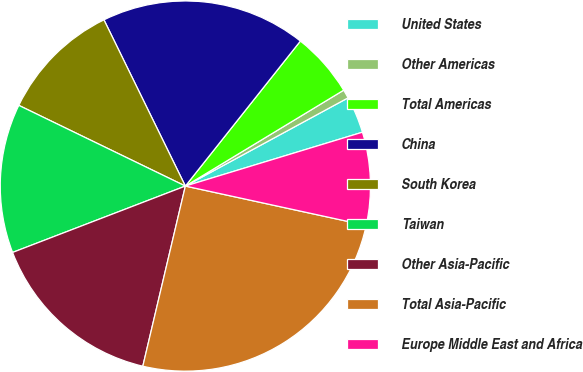Convert chart to OTSL. <chart><loc_0><loc_0><loc_500><loc_500><pie_chart><fcel>United States<fcel>Other Americas<fcel>Total Americas<fcel>China<fcel>South Korea<fcel>Taiwan<fcel>Other Asia-Pacific<fcel>Total Asia-Pacific<fcel>Europe Middle East and Africa<nl><fcel>3.21%<fcel>0.76%<fcel>5.66%<fcel>17.92%<fcel>10.57%<fcel>13.02%<fcel>15.47%<fcel>25.28%<fcel>8.11%<nl></chart> 